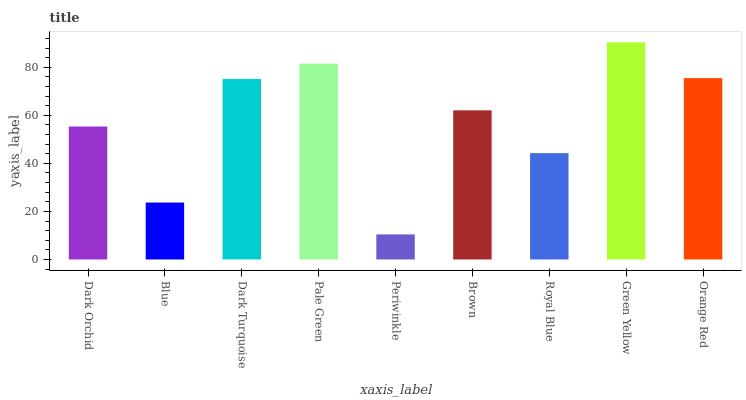Is Blue the minimum?
Answer yes or no. No. Is Blue the maximum?
Answer yes or no. No. Is Dark Orchid greater than Blue?
Answer yes or no. Yes. Is Blue less than Dark Orchid?
Answer yes or no. Yes. Is Blue greater than Dark Orchid?
Answer yes or no. No. Is Dark Orchid less than Blue?
Answer yes or no. No. Is Brown the high median?
Answer yes or no. Yes. Is Brown the low median?
Answer yes or no. Yes. Is Green Yellow the high median?
Answer yes or no. No. Is Green Yellow the low median?
Answer yes or no. No. 